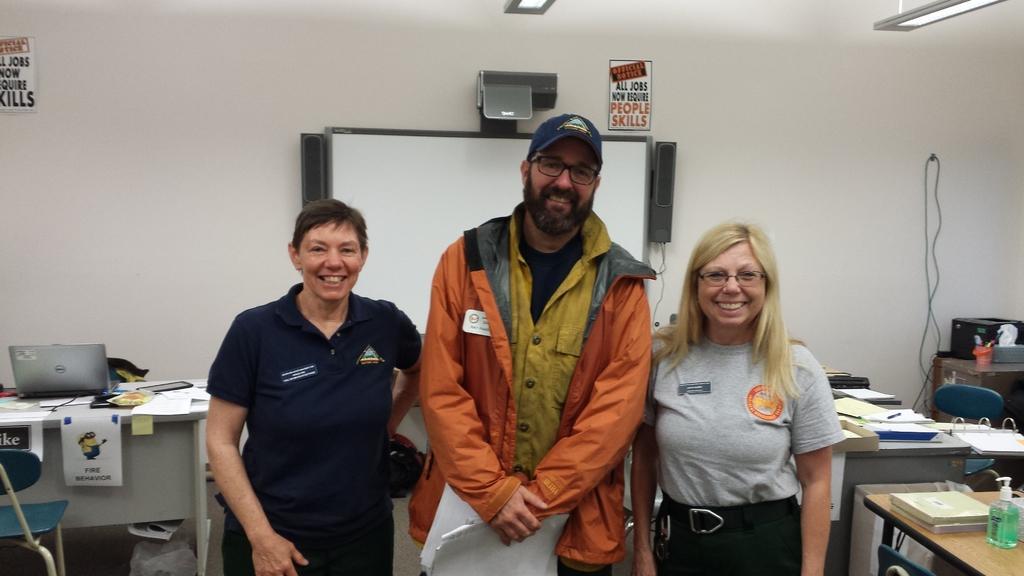Could you give a brief overview of what you see in this image? In this image we can see this three people are standing. In the background we can see laptop and papers on table. Also we can see monitor, speakers and lights on ceiling. 